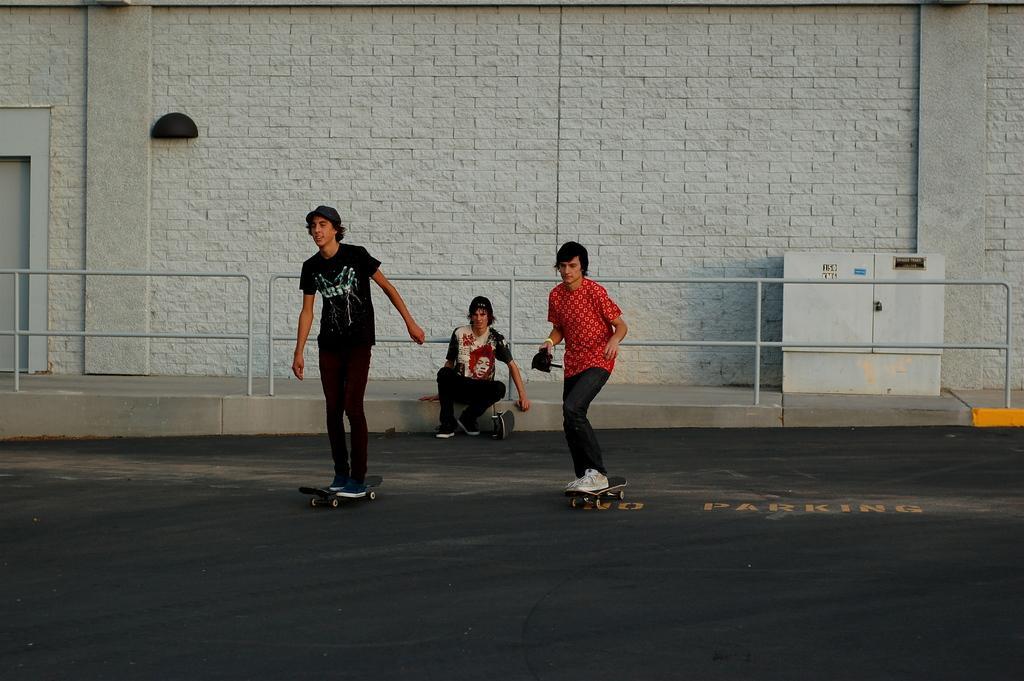Please provide a concise description of this image. In this picture we can see two persons skating on skateboards, there is a person sitting in the middle, in the background there is a wall, we can see a box on the right side. 